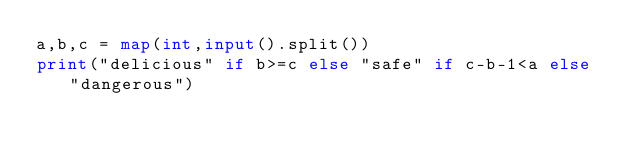Convert code to text. <code><loc_0><loc_0><loc_500><loc_500><_Python_>a,b,c = map(int,input().split())
print("delicious" if b>=c else "safe" if c-b-1<a else "dangerous")</code> 